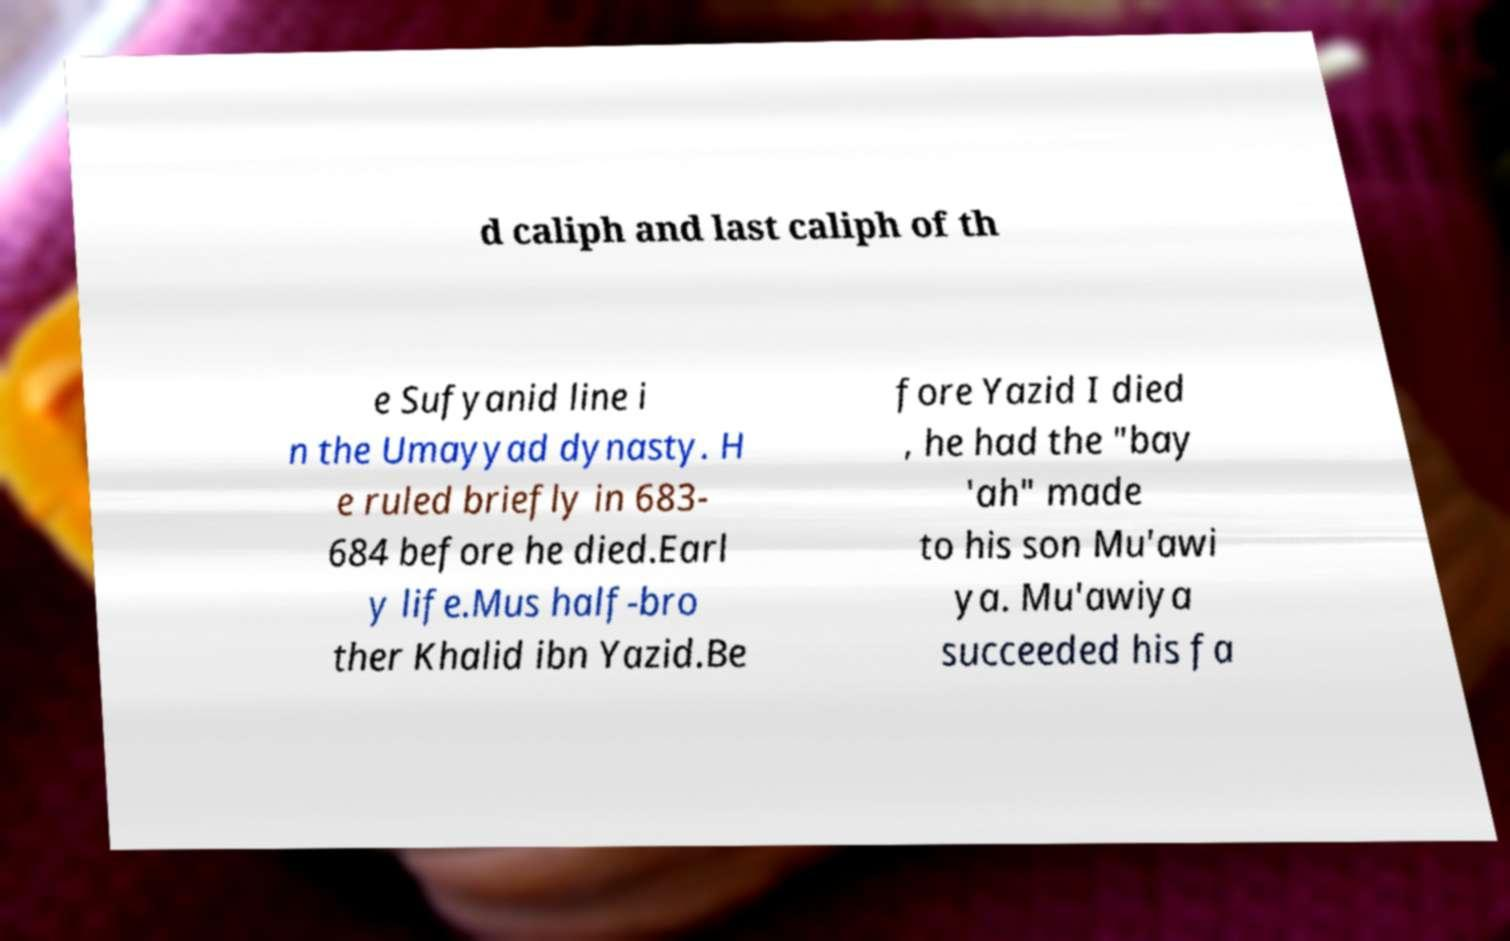Can you read and provide the text displayed in the image?This photo seems to have some interesting text. Can you extract and type it out for me? d caliph and last caliph of th e Sufyanid line i n the Umayyad dynasty. H e ruled briefly in 683- 684 before he died.Earl y life.Mus half-bro ther Khalid ibn Yazid.Be fore Yazid I died , he had the "bay 'ah" made to his son Mu'awi ya. Mu'awiya succeeded his fa 